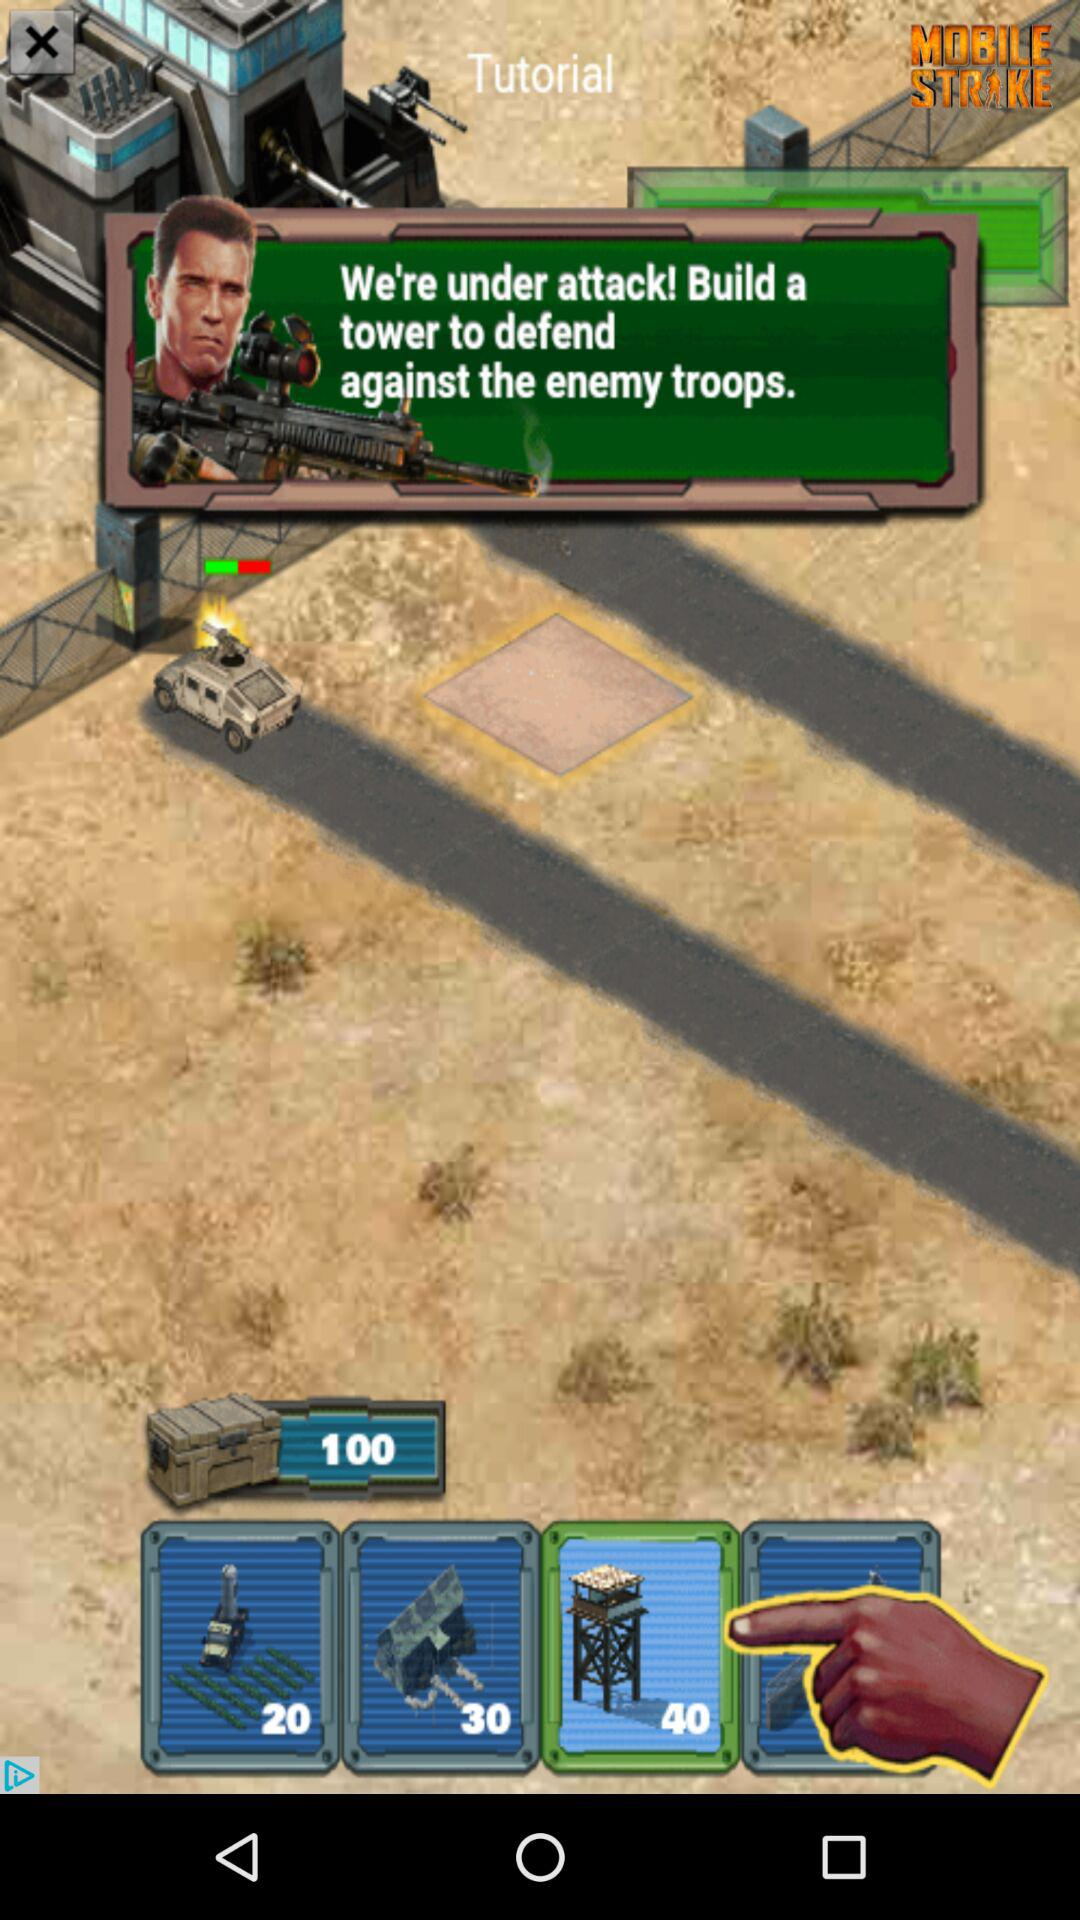What is the application name? The application name is "MOBILE STRIKE". 